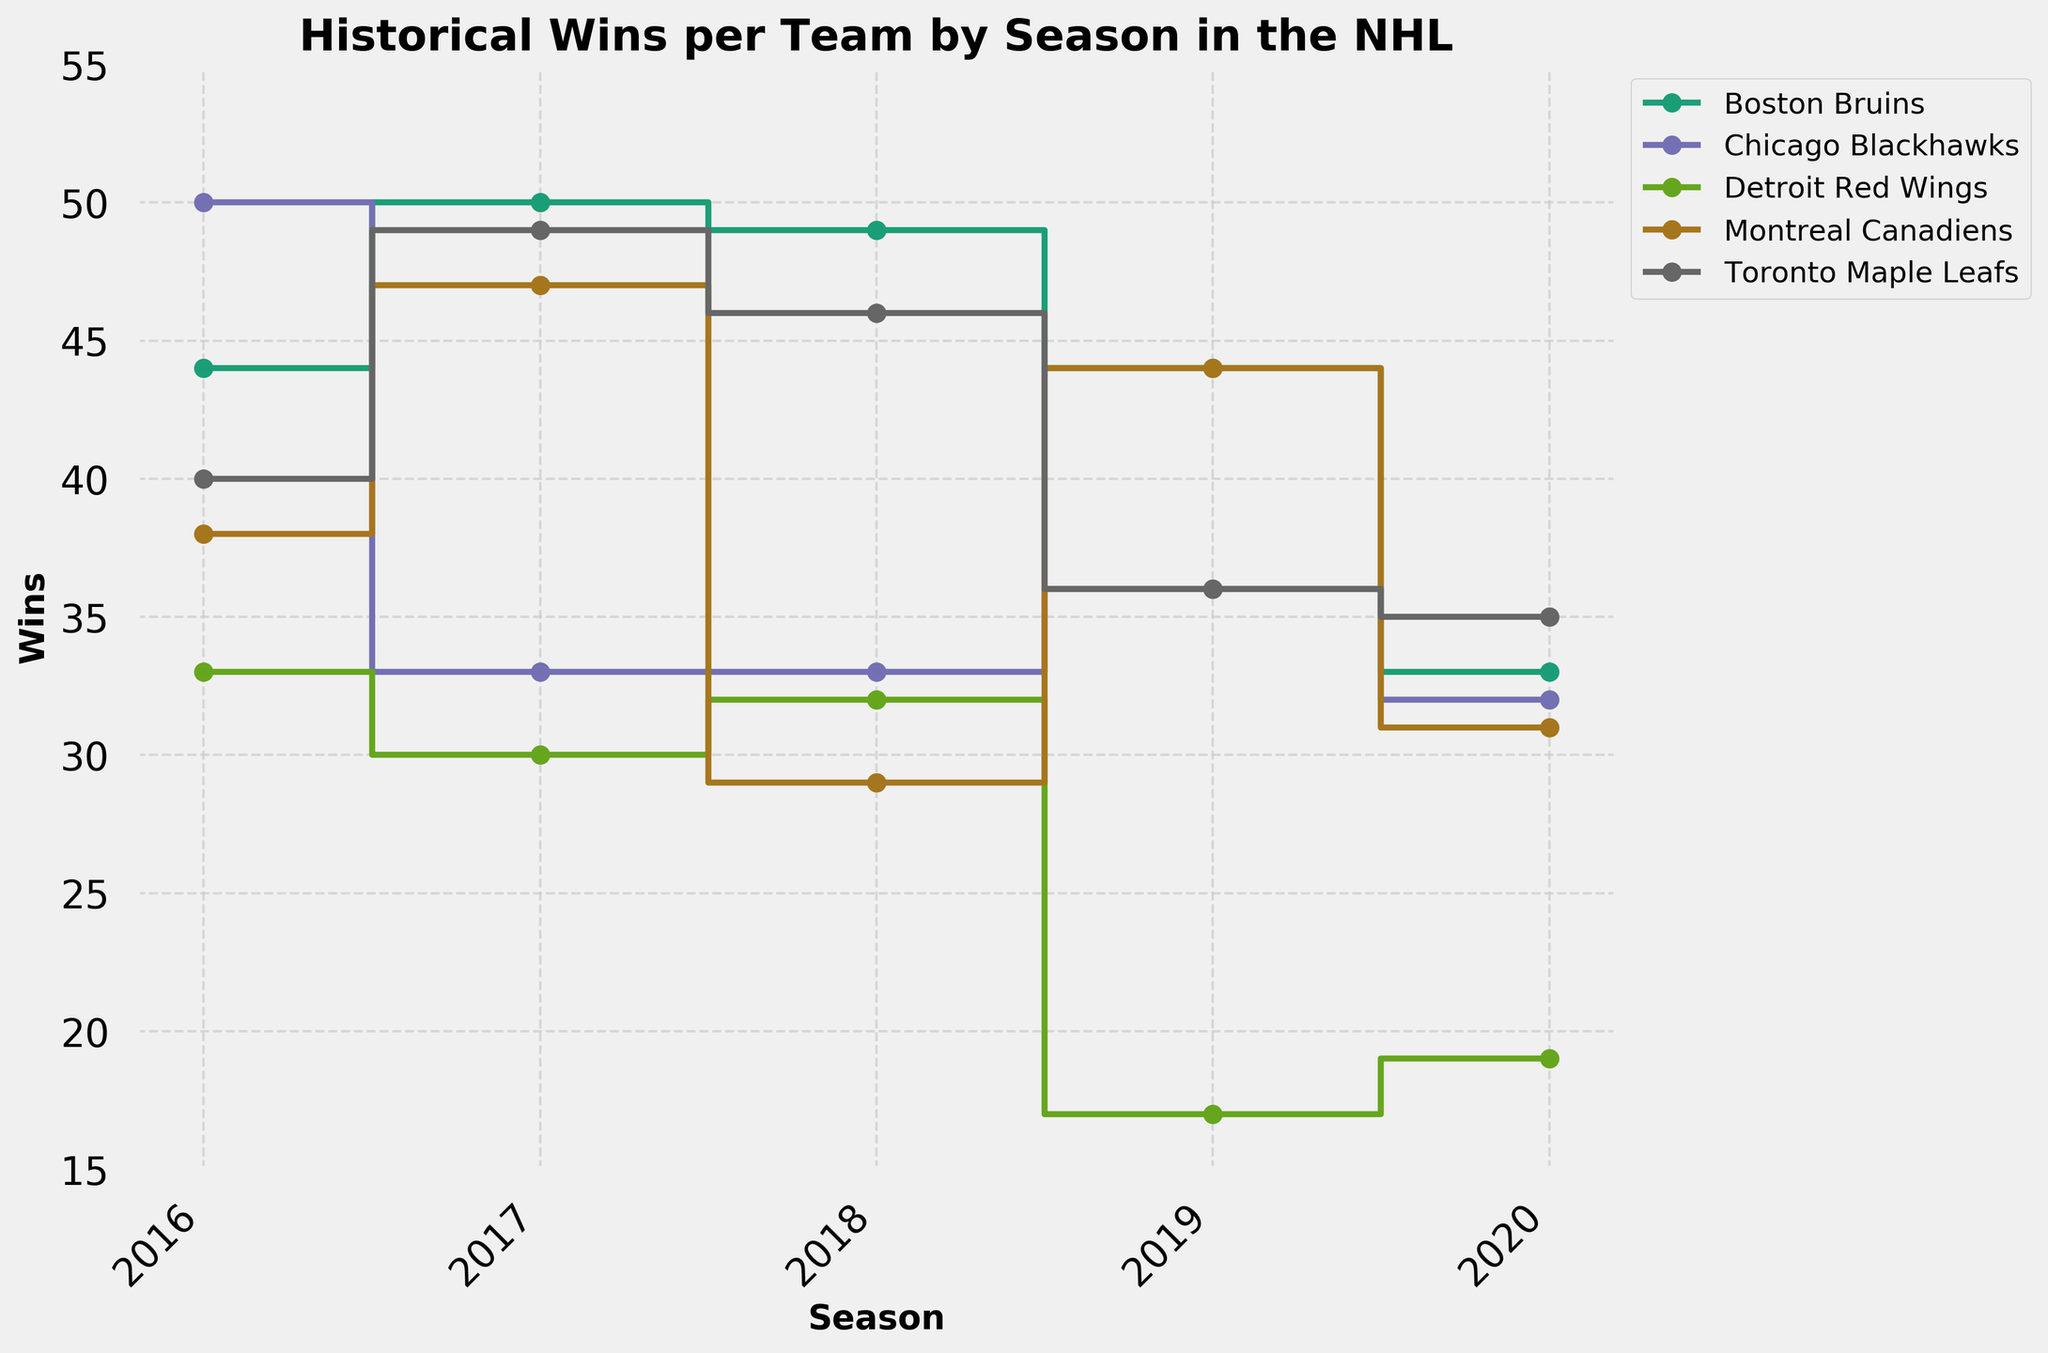What is the main title of the stair plot? The main title of the stair plot is located at the top of the plot and summarizes what the figure is about. It reads 'Historical Wins per Team by Season in the NHL'.
Answer: Historical Wins per Team by Season in the NHL Which team had the highest number of wins in the 2017 season? Locate the markers on the plot for the 2017 season along the x-axis and identify the highest point among them. The Boston Bruins had the highest number of wins in 2017 with 50 wins.
Answer: Boston Bruins What is the range of wins displayed on the y-axis in the plot? The y-axis represents the number of wins and is labeled on the left side of the plot. It ranges from 15 to 55 wins.
Answer: 15 to 55 How did the win counts of the Montreal Canadiens change from 2016 to 2020? Trace the markers for the Montreal Canadiens from the 2016 to 2020 seasons. Their win counts were 38, 47, 29, 44, and 31 respectively.
Answer: 38, 47, 29, 44, 31 Which team had the most substantial drop in wins between any two consecutive seasons? Identify the biggest vertical drop between any two consecutive markers for each team. The Chicago Blackhawks experienced a significant drop in wins from 50 in 2016 to 33 in 2017.
Answer: Chicago Blackhawks In which season did the Toronto Maple Leafs have their highest number of wins? Look at the markers and lines for the Toronto Maple Leafs and identify the peak point across all seasons. The highest number of wins for the Toronto Maple Leafs was in 2017 with 49 wins.
Answer: 2017 How many teams had fewer than 20 wins in any of the seasons shown? Identify the data points that fall below the 20 wins threshold on the y-axis. Only the Detroit Red Wings had fewer than 20 wins in the 2019 and 2020 seasons.
Answer: 1 Did any team maintain the same number of wins for three consecutive seasons? Examine the data points for each team to check for flat sections in the plot over three seasons. The Chicago Blackhawks maintained 33 wins for the 2017 and 2018 seasons but not three consecutive seasons.
Answer: No How many wins did the Detroit Red Wings achieve in the 2019 season, and how does this compare to their wins in 2020? Identify the markers for the Detroit Red Wings in 2019 and 2020. They had 17 wins in 2019 and 19 in 2020, indicating a slight increase.
Answer: 17 in 2019, 19 in 2020 Which team showed the most consistent performance in terms of wins across all seasons? Observe the fluctuations in the number of wins for each team. The Boston Bruins and Montreal Canadiens showed some fluctuations, while Detroit had the most ups and downs. The Toronto Maple Leafs had consistent high-performance seasons without significant drops.
Answer: Toronto Maple Leafs 